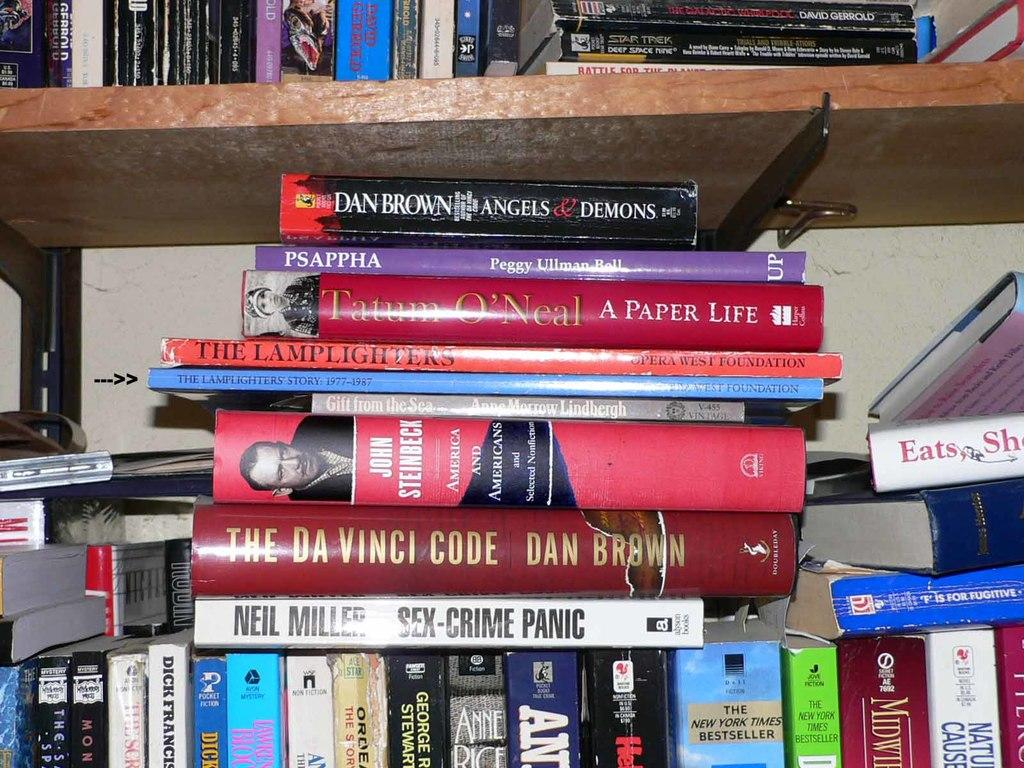<image>
Provide a brief description of the given image. A bookshelf full of books with a book titled Sex-Crime Panic. 